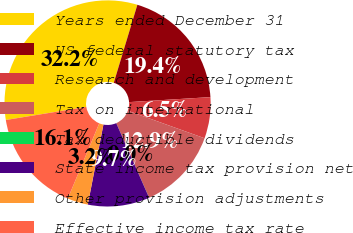Convert chart to OTSL. <chart><loc_0><loc_0><loc_500><loc_500><pie_chart><fcel>Years ended December 31<fcel>US federal statutory tax<fcel>Research and development<fcel>Tax on international<fcel>Tax deductible dividends<fcel>State income tax provision net<fcel>Other provision adjustments<fcel>Effective income tax rate<nl><fcel>32.24%<fcel>19.35%<fcel>6.46%<fcel>12.9%<fcel>0.01%<fcel>9.68%<fcel>3.23%<fcel>16.13%<nl></chart> 